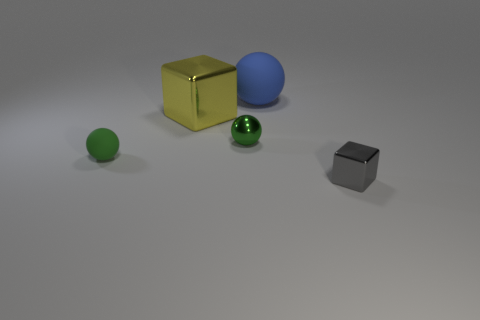Are there the same number of big yellow objects that are right of the big matte object and blue matte spheres?
Offer a terse response. No. Is the color of the object that is in front of the small rubber sphere the same as the metal thing that is on the left side of the tiny green metal sphere?
Ensure brevity in your answer.  No. There is a thing that is both to the right of the large yellow cube and on the left side of the blue ball; what material is it made of?
Your answer should be compact. Metal. What color is the tiny rubber ball?
Make the answer very short. Green. What number of other things are there of the same shape as the green shiny object?
Provide a succinct answer. 2. Are there an equal number of big blue matte objects that are to the right of the gray metallic cube and gray objects that are behind the small shiny ball?
Give a very brief answer. Yes. What is the big block made of?
Make the answer very short. Metal. What is the big object that is to the left of the blue matte sphere made of?
Your response must be concise. Metal. Is there anything else that is the same material as the yellow thing?
Keep it short and to the point. Yes. Are there more large blue rubber balls that are on the left side of the blue matte object than big things?
Offer a terse response. No. 